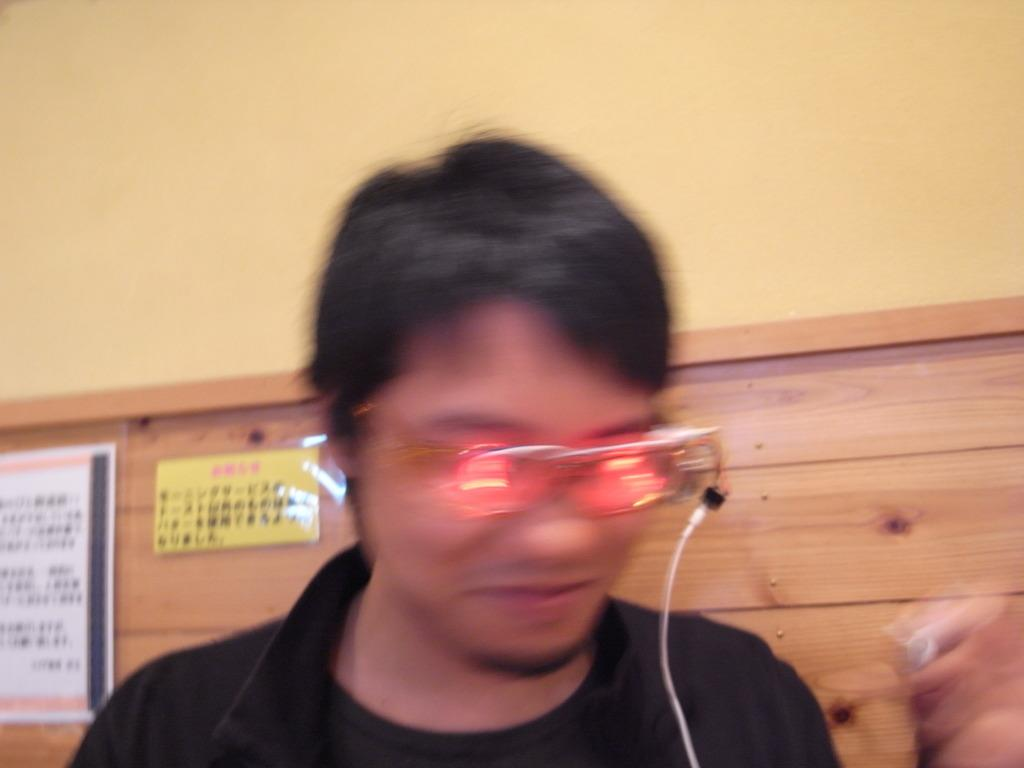What can be seen in the background of the image? There is a wall, a notice board, and posters in the background of the image. What is the person in the image wearing? The person in the image is wearing goggles. Is there any text or information visible on the notice board? The provided facts do not mention any specific text or information on the notice board. Why might the right side of the image be blurry? The reason for the blurriness on the right side of the image is not mentioned in the provided facts. Can you see a giraffe playing basketball in the image? No, there is no giraffe or basketball present in the image. Is there a hall visible in the image? The provided facts do not mention a hall being present in the image. 